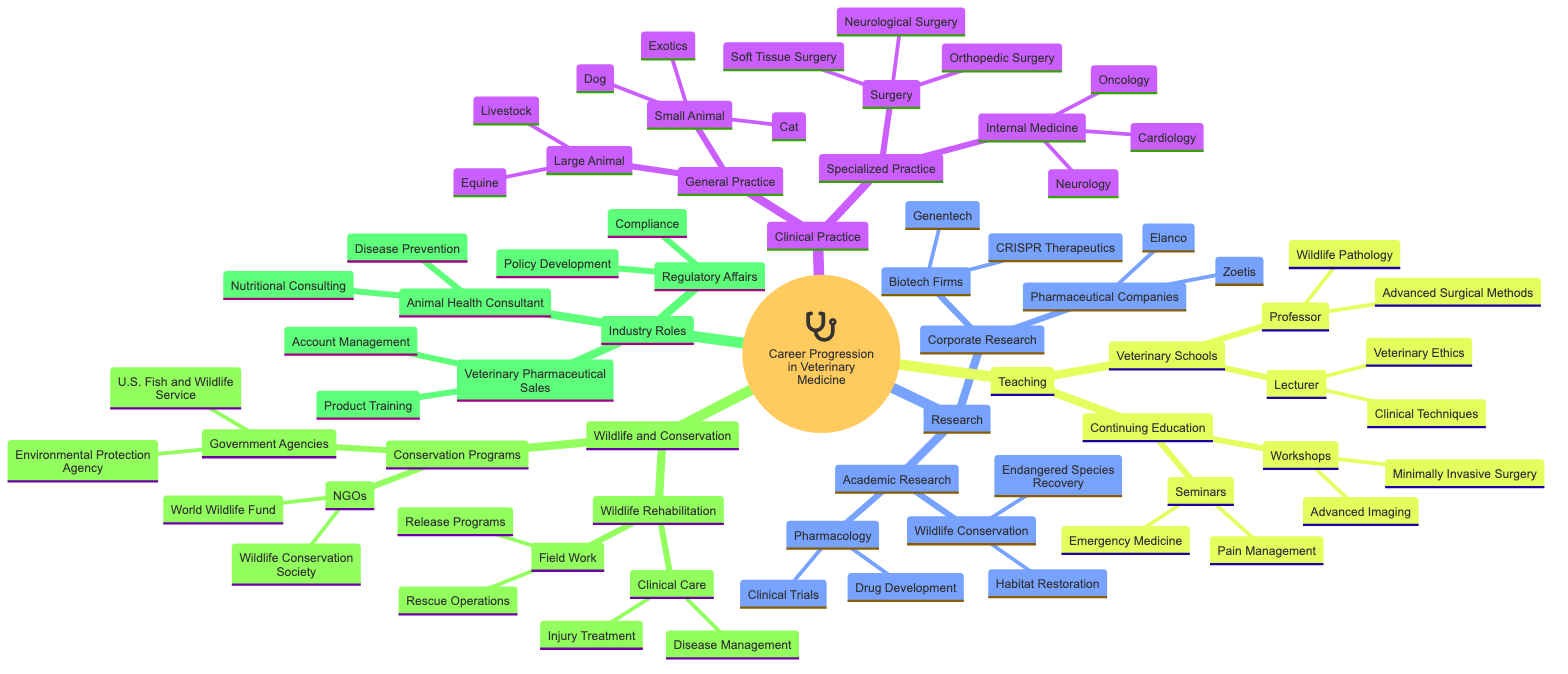What are the two main areas under Clinical Practice? The diagram shows "General Practice" and "Specialized Practice" as the two main branches under the Clinical Practice category.
Answer: General Practice, Specialized Practice How many types of Research are there in the diagram? Counting the main branches under Research, there are two types: Academic Research and Corporate Research.
Answer: 2 What is one example of a role in Teaching? The Teaching branch has roles listed such as Lecturer and Professor, which are two examples of positions that can be found there.
Answer: Lecturer What are the two types of Wildlife and Conservation activities listed in the diagram? Looking at the Wildlife and Conservation section, the activities are split into Wildlife Rehabilitation and Conservation Programs.
Answer: Wildlife Rehabilitation, Conservation Programs Which type of Veterinary Practice includes Soft Tissue Surgery? The type of Veterinary Practice that encompasses Soft Tissue Surgery falls under Specialized Practice, specifically under the Surgery category.
Answer: Specialized Practice How many species are mentioned under Small Animal in General Practice? The Small Animal section lists three species (Dog, Cat, Exotics), so by counting these, the total is three.
Answer: 3 What is a common role in Industry Roles specifically related to sales? In the Industry Roles section, the Veterinary Pharmaceutical Sales type includes roles, of which Account Management is a specified example.
Answer: Account Management What type of conservation focus is under Academic Research? The Academic Research branch shows Wildlife Conservation as a specific focus area, highlighting conservation as a primary research topic.
Answer: Wildlife Conservation What are the two main categories of Continuing Education mentioned? The Continuing Education branch includes Workshops and Seminars as its two main categories.
Answer: Workshops, Seminars 